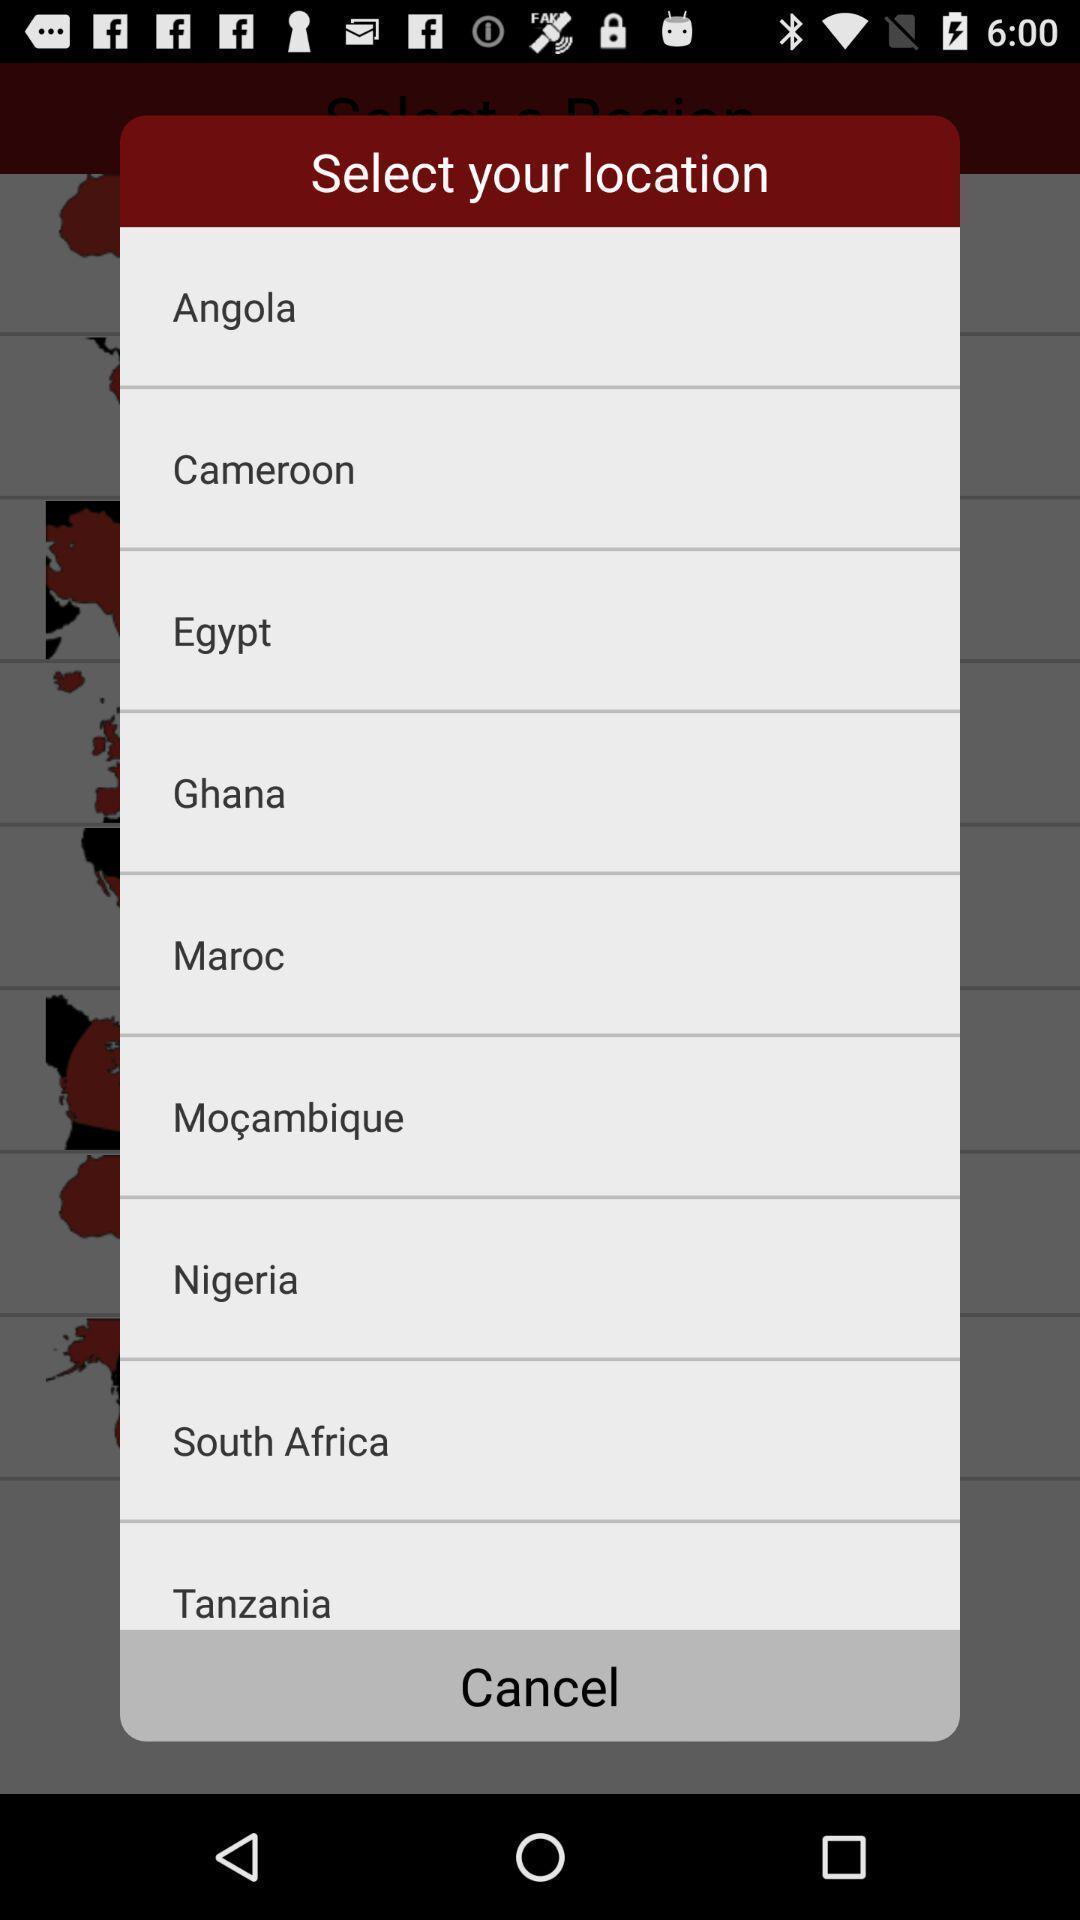Please provide a description for this image. Pop-up with list of options to choose a location. 